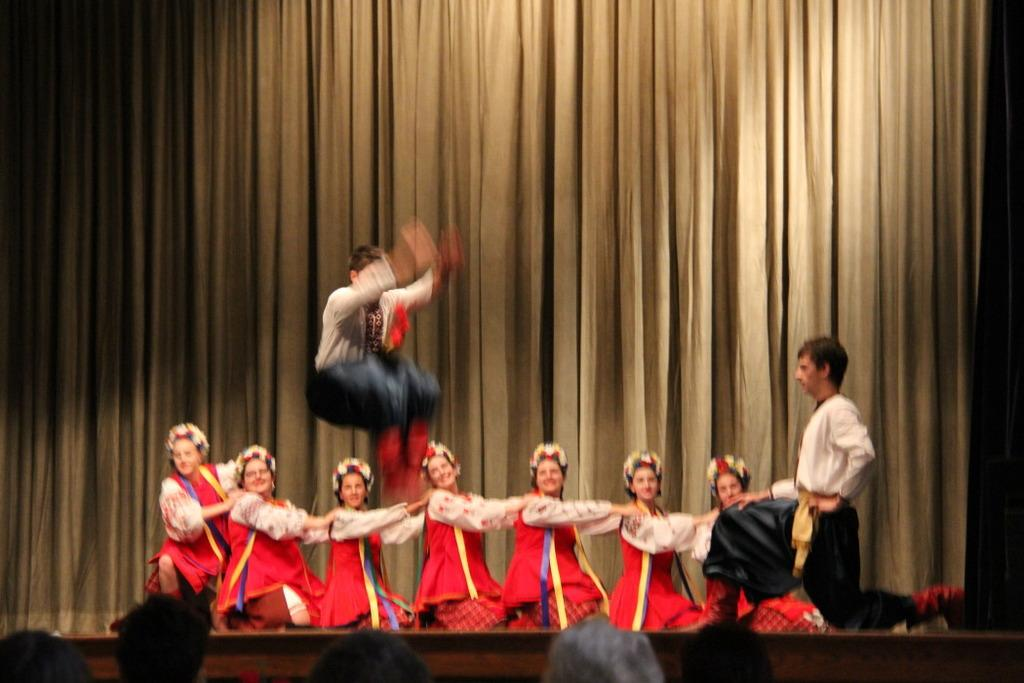What are the people in the image doing? The people in the image are wearing costumes and performing. Can you describe the action of one of the performers? Yes, there is a man jumping in the image. Where are the people located in the image? There are people at the bottom of the image. What can be seen in the background of the image? There is a curtain in the background of the image. What time is displayed on the clock in the image? There is no clock present in the image. On which stage are the performers standing in the image? The image does not show a stage; it only shows the performers and the curtain in the background. 